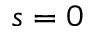Convert formula to latex. <formula><loc_0><loc_0><loc_500><loc_500>s = 0</formula> 